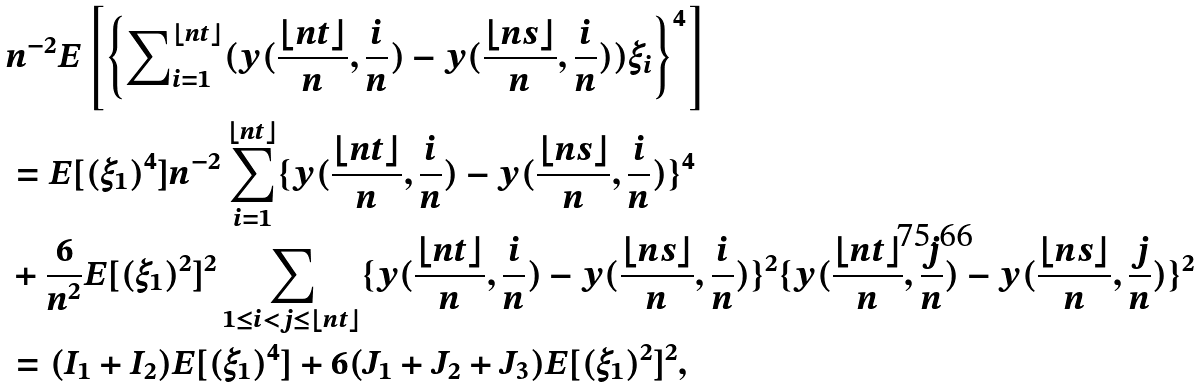Convert formula to latex. <formula><loc_0><loc_0><loc_500><loc_500>& n ^ { - 2 } E \left [ \left \{ \sum \nolimits _ { i = 1 } ^ { \lfloor n t \rfloor } ( y ( \frac { \lfloor n t \rfloor } { n } , \frac { i } { n } ) - y ( \frac { \lfloor n s \rfloor } { n } , \frac { i } { n } ) ) \xi _ { i } \right \} ^ { 4 } \right ] \\ & = E [ ( \xi _ { 1 } ) ^ { 4 } ] n ^ { - 2 } \sum _ { i = 1 } ^ { \lfloor n t \rfloor } \{ y ( \frac { \lfloor n t \rfloor } { n } , \frac { i } { n } ) - y ( \frac { \lfloor n s \rfloor } { n } , \frac { i } { n } ) \} ^ { 4 } \\ & + \frac { 6 } { n ^ { 2 } } E [ ( \xi _ { 1 } ) ^ { 2 } ] ^ { 2 } \sum _ { 1 \leq i < j \leq \lfloor n t \rfloor } \{ y ( \frac { \lfloor n t \rfloor } { n } , \frac { i } { n } ) - y ( \frac { \lfloor n s \rfloor } { n } , \frac { i } { n } ) \} ^ { 2 } \{ y ( \frac { \lfloor n t \rfloor } { n } , \frac { j } { n } ) - y ( \frac { \lfloor n s \rfloor } { n } , \frac { j } { n } ) \} ^ { 2 } \\ & = ( I _ { 1 } + I _ { 2 } ) E [ ( \xi _ { 1 } ) ^ { 4 } ] + 6 ( J _ { 1 } + J _ { 2 } + J _ { 3 } ) E [ ( \xi _ { 1 } ) ^ { 2 } ] ^ { 2 } ,</formula> 